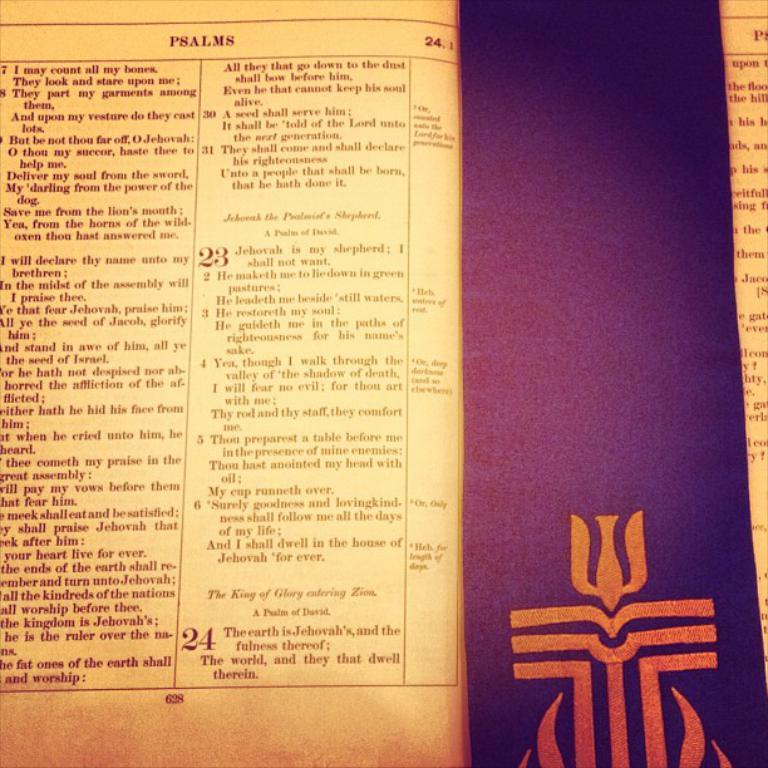<image>
Give a short and clear explanation of the subsequent image. A page in an older book with psalms 23 and 24 on it 